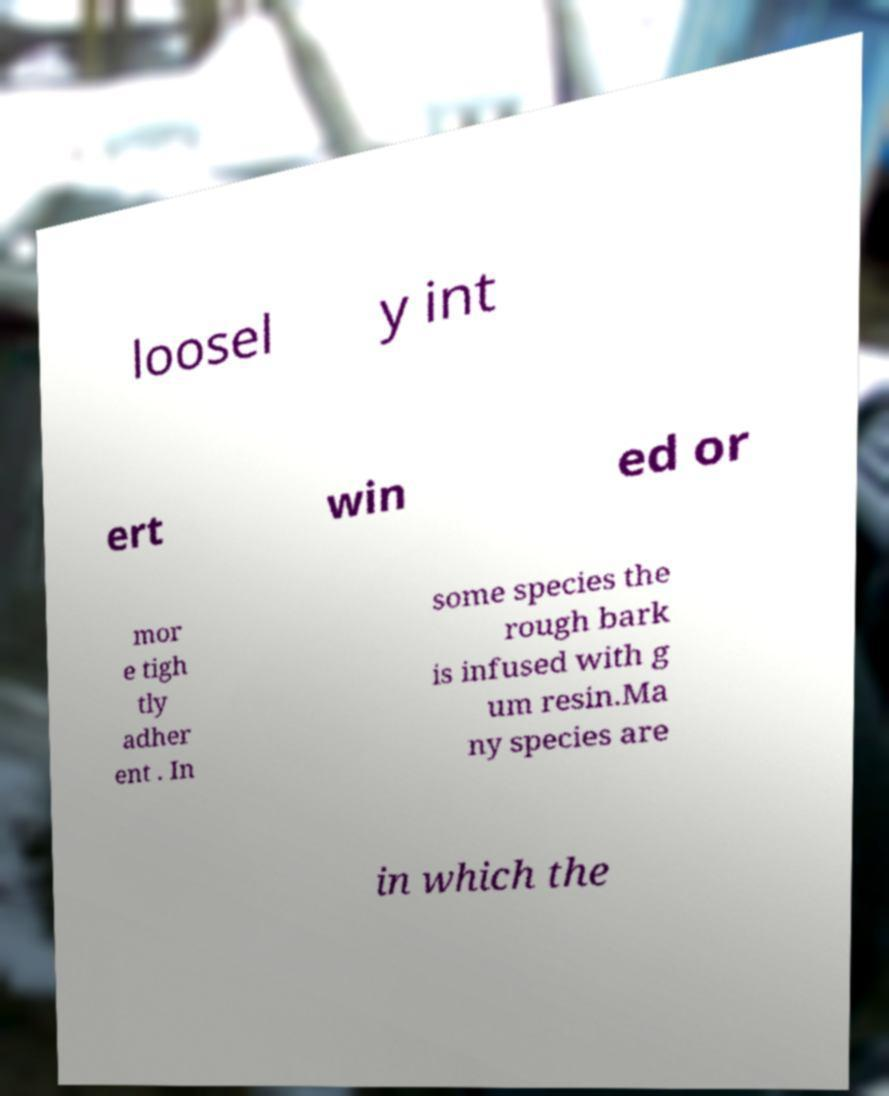Please identify and transcribe the text found in this image. loosel y int ert win ed or mor e tigh tly adher ent . In some species the rough bark is infused with g um resin.Ma ny species are in which the 